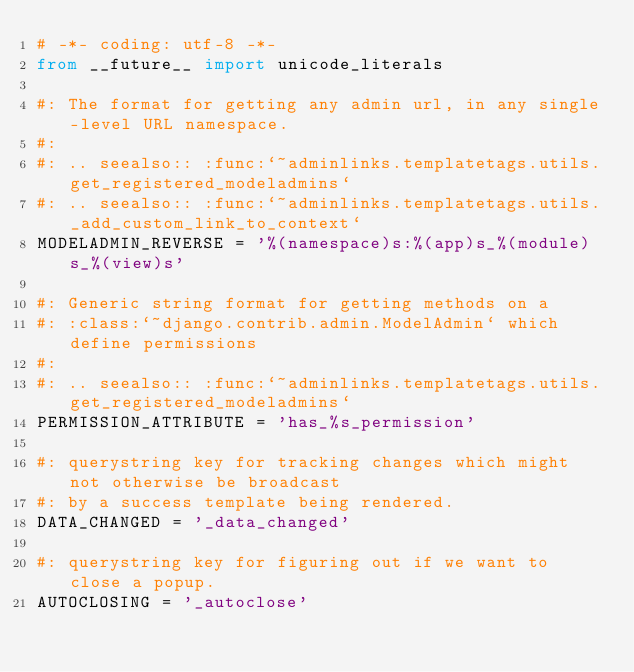Convert code to text. <code><loc_0><loc_0><loc_500><loc_500><_Python_># -*- coding: utf-8 -*-
from __future__ import unicode_literals

#: The format for getting any admin url, in any single-level URL namespace.
#:
#: .. seealso:: :func:`~adminlinks.templatetags.utils.get_registered_modeladmins`
#: .. seealso:: :func:`~adminlinks.templatetags.utils._add_custom_link_to_context`
MODELADMIN_REVERSE = '%(namespace)s:%(app)s_%(module)s_%(view)s'

#: Generic string format for getting methods on a
#: :class:`~django.contrib.admin.ModelAdmin` which define permissions
#:
#: .. seealso:: :func:`~adminlinks.templatetags.utils.get_registered_modeladmins`
PERMISSION_ATTRIBUTE = 'has_%s_permission'

#: querystring key for tracking changes which might not otherwise be broadcast
#: by a success template being rendered.
DATA_CHANGED = '_data_changed'

#: querystring key for figuring out if we want to close a popup.
AUTOCLOSING = '_autoclose'
</code> 